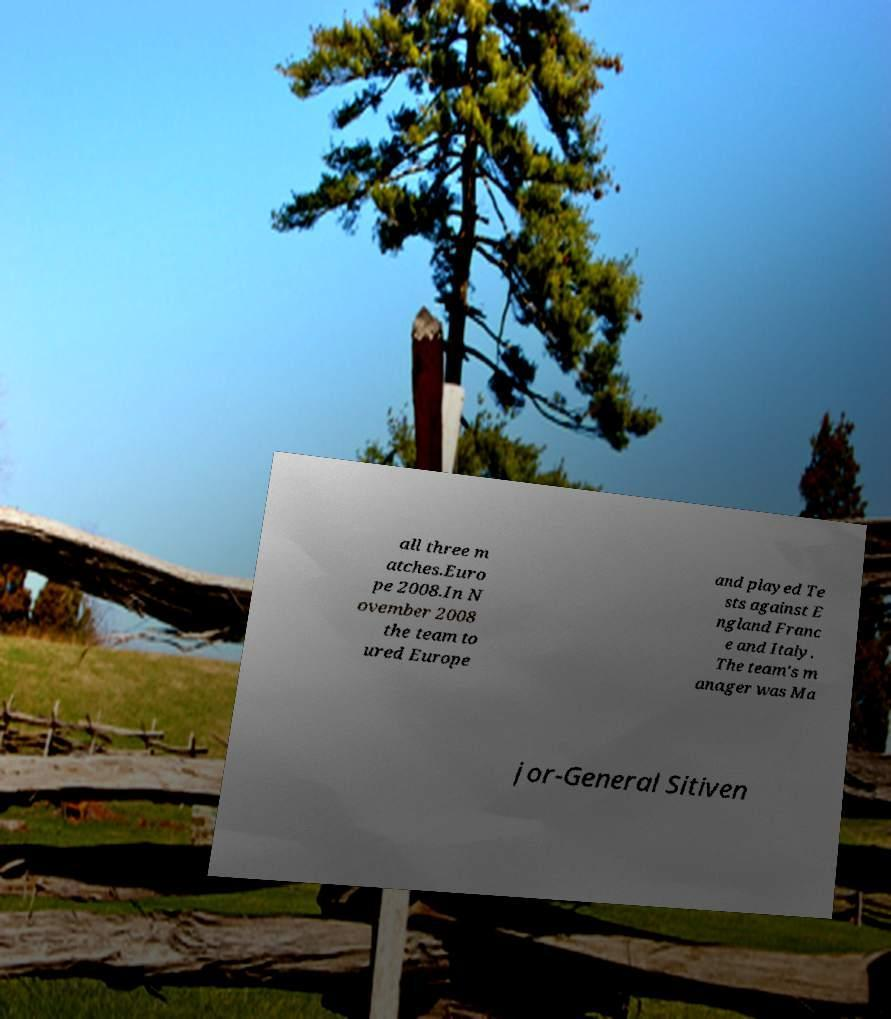Could you assist in decoding the text presented in this image and type it out clearly? all three m atches.Euro pe 2008.In N ovember 2008 the team to ured Europe and played Te sts against E ngland Franc e and Italy. The team's m anager was Ma jor-General Sitiven 